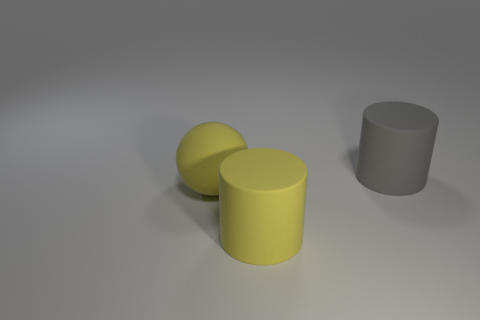Add 1 big gray metal cylinders. How many objects exist? 4 Subtract all yellow cylinders. How many cylinders are left? 1 Subtract all spheres. How many objects are left? 2 Subtract 1 cylinders. How many cylinders are left? 1 Subtract all large yellow rubber objects. Subtract all matte balls. How many objects are left? 0 Add 3 big yellow things. How many big yellow things are left? 5 Add 3 small gray matte balls. How many small gray matte balls exist? 3 Subtract 0 blue blocks. How many objects are left? 3 Subtract all red balls. Subtract all yellow cubes. How many balls are left? 1 